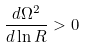Convert formula to latex. <formula><loc_0><loc_0><loc_500><loc_500>\frac { d \Omega ^ { 2 } } { d \ln R } > 0</formula> 